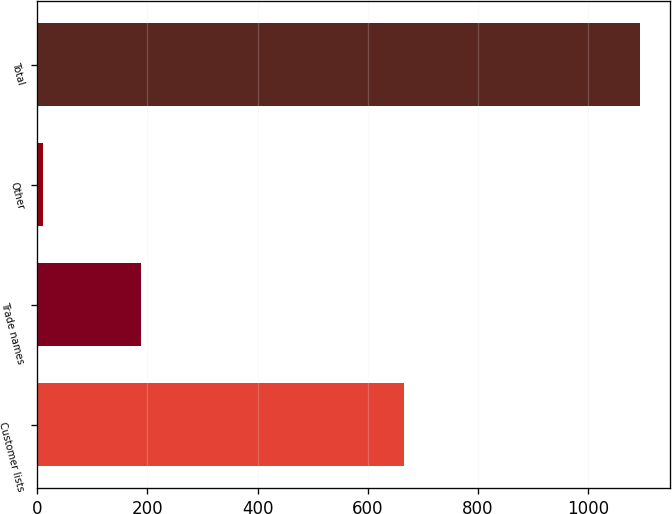<chart> <loc_0><loc_0><loc_500><loc_500><bar_chart><fcel>Customer lists<fcel>Trade names<fcel>Other<fcel>Total<nl><fcel>666.3<fcel>189.4<fcel>10.6<fcel>1094.8<nl></chart> 